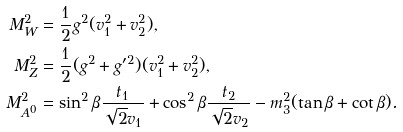Convert formula to latex. <formula><loc_0><loc_0><loc_500><loc_500>M _ { W } ^ { 2 } & = \frac { 1 } { 2 } g ^ { 2 } ( v _ { 1 } ^ { 2 } + v _ { 2 } ^ { 2 } ) , \\ M _ { Z } ^ { 2 } & = \frac { 1 } { 2 } ( g ^ { 2 } + g ^ { \prime 2 } ) ( v _ { 1 } ^ { 2 } + v _ { 2 } ^ { 2 } ) , \\ M _ { A ^ { 0 } } ^ { 2 } & = \sin ^ { 2 } \beta \frac { t _ { 1 } } { \sqrt { 2 } v _ { 1 } } + \cos ^ { 2 } \beta \frac { t _ { 2 } } { \sqrt { 2 } v _ { 2 } } - m _ { 3 } ^ { 2 } ( \tan \beta + \cot \beta ) .</formula> 